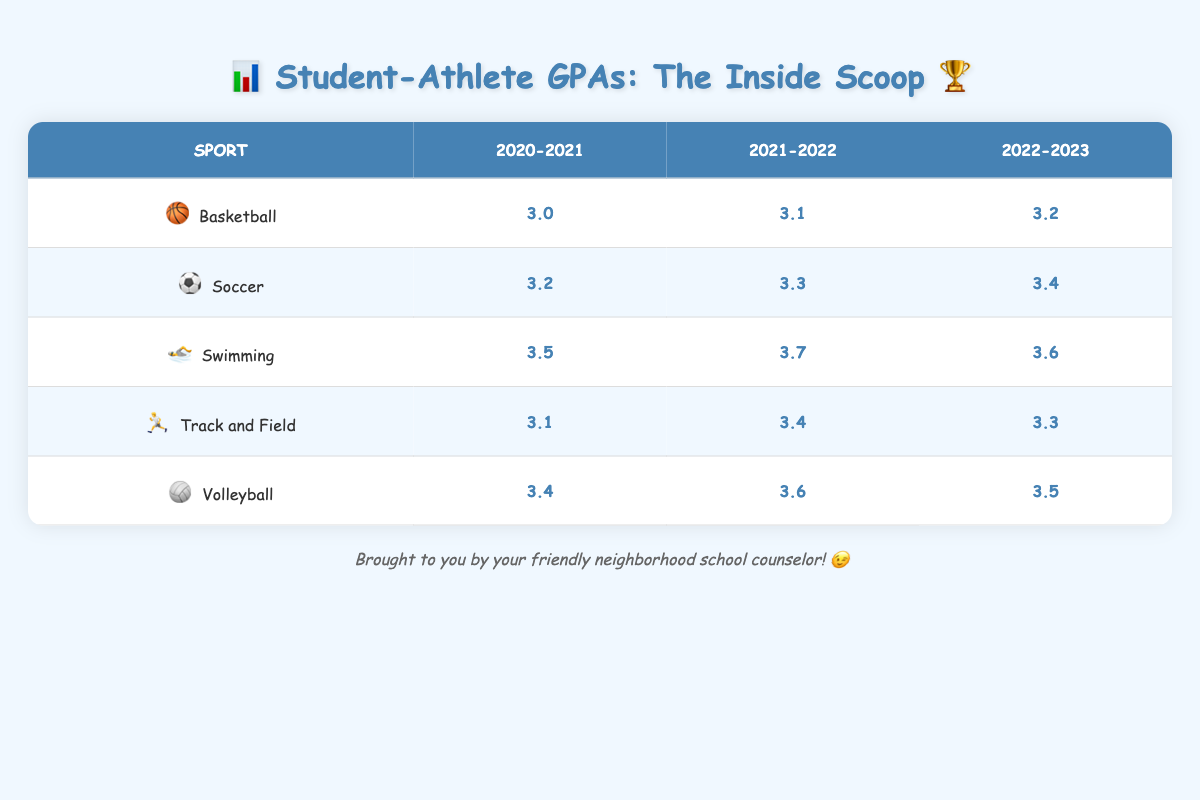What is the average GPA of student-athletes in Soccer for the academic year 2022-2023? According to the table, the average GPA for Soccer in the 2022-2023 academic year is directly listed. It is 3.4.
Answer: 3.4 Which sport had the highest average GPA in the academic year 2021-2022? In the 2021-2022 academic year, Swimming has the highest GPA, which is 3.7, as compared to the other sports listed in that year.
Answer: Swimming Did the average GPA for Basketball increase from 2020-2021 to 2022-2023? The average GPA for Basketball in 2020-2021 was 3.0, and it increased to 3.2 in 2022-2023. This confirms that the average GPA for Basketball did increase over the years.
Answer: Yes What is the difference in average GPA for Swimming between the academic years 2021-2022 and 2022-2023? In 2021-2022, the average GPA for Swimming was 3.7, and in 2022-2023, it was 3.6. The difference is calculated by subtracting 3.6 from 3.7, which equals 0.1.
Answer: 0.1 Which sport showed a decline in average GPA from 2021-2022 to 2022-2023? By comparing the average GPAs from each year for all sports, we can see that Track and Field declined from 3.4 in 2021-2022 to 3.3 in 2022-2023. Therefore, Track and Field is the sport that showed a decline.
Answer: Track and Field 